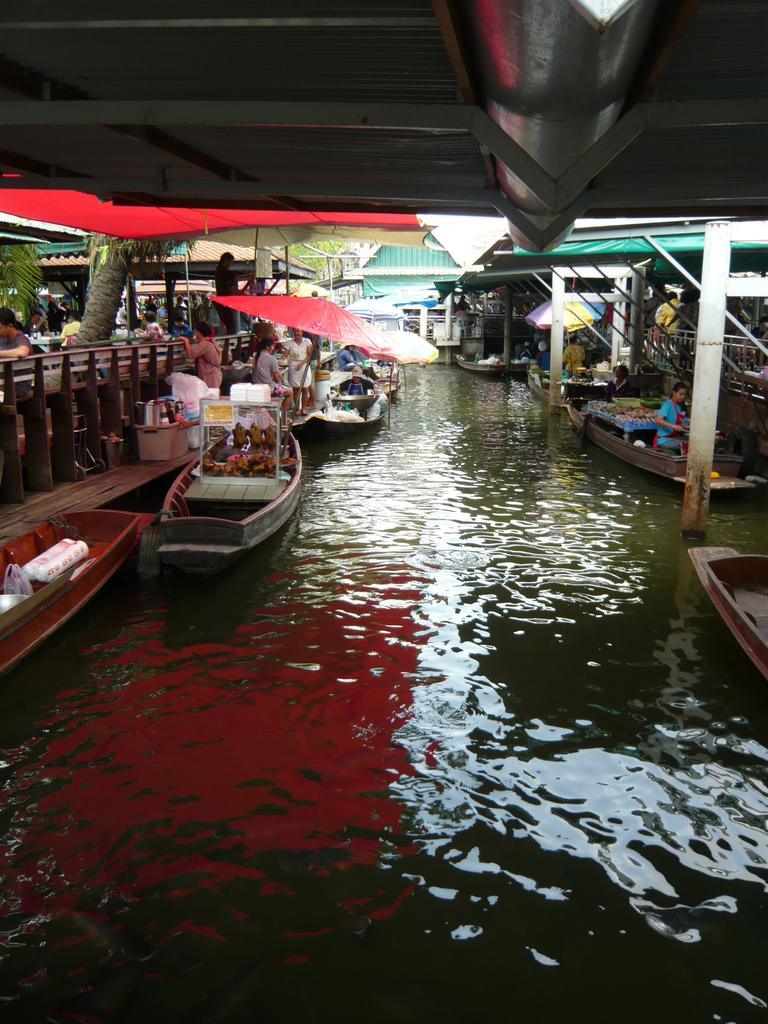How many people are in the image? There are people in the image, but the exact number is not specified. What is above the water in the image? There are boats above the water in the image. What type of structures can be seen in the image? Pipes and sheds are visible in the image. What is contained within a transparent structure in the image? There is a glass box in the image, and it likely contains objects. What is the natural element present in the image? A tree trunk is present in the image. How many cupcakes are on the table in the image? There is no table or cupcakes present in the image. What type of sack is being used to carry the cakes in the image? There are no cakes or sacks present in the image. 